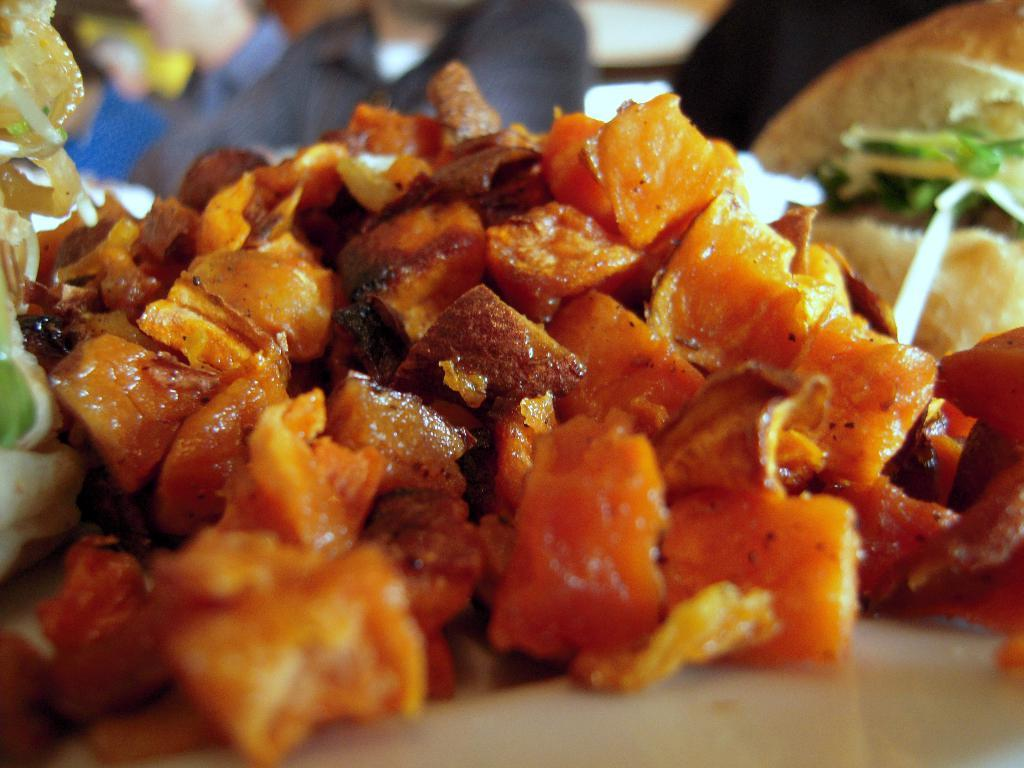What types of items are visible in the image? There are food items in the image. Where are the food items located? The food items are on an object. Can you describe the background of the image? The background of the image is blurred. What type of decision can be seen being made by the ants in the image? There are no ants present in the image, so no decision can be observed. What can be used to cut the food items in the image? There is no scissors present in the image to cut the food items. 